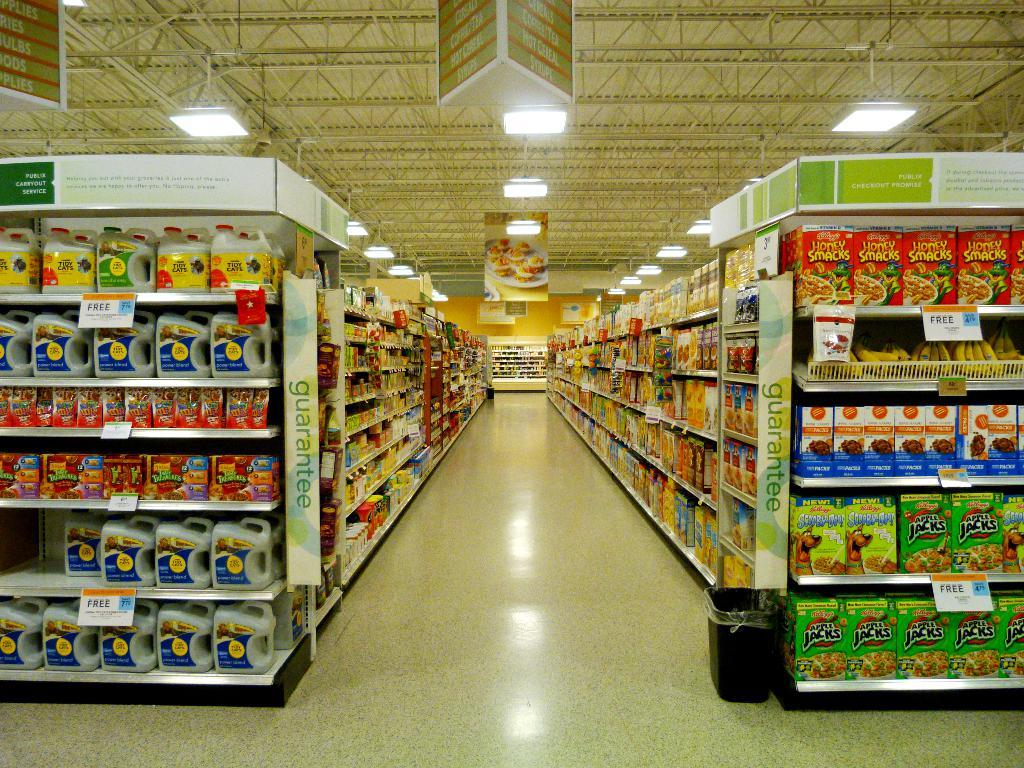What type of establishment is shown in the image? The image depicts a mart. What can be found inside the mart? There are shelves in the mart, and items are arranged on the shelves. How is the mart illuminated? There are lights in the mart. What is on the roof of the mart? There are boards on the roof of the mart. How many ladybugs can be seen crawling on the shelves in the image? There are no ladybugs present in the image; it only shows shelves with items arranged on them. 